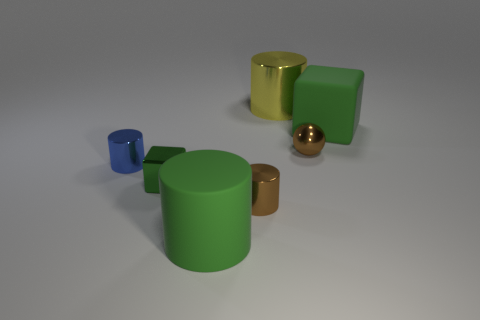What impression do the colors of the objects give you about the setting? The colors of the objects – blue, green, golden, and copper – give a sense of variety and contrast against the neutral background. They create a calming but diverse palette that might suggest this setting is designed to display these objects clearly, possibly for an artistic or illustrative purpose. 